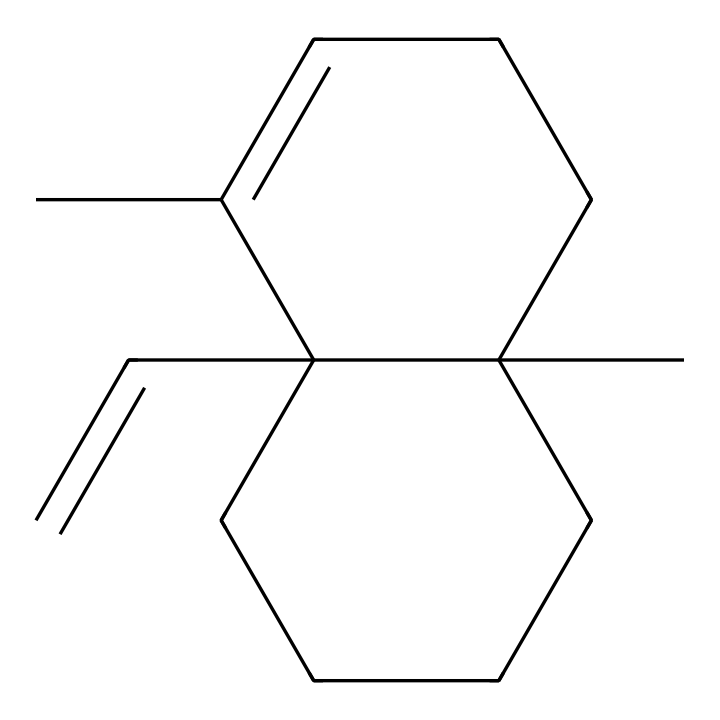What is the molecular formula of caryophyllene? To find the molecular formula, we count the number of carbon (C) and hydrogen (H) atoms in the structure. In the provided SMILES representation, there are 15 Carbon atoms and 24 Hydrogen atoms, leading to the molecular formula C15H24.
Answer: C15H24 How many rings are present in caryophyllene? The structure contains a bicyclic system, which indicates there are two rings in the compound. These rings are formed by connecting the carbons in the main chain, as seen in the structure.
Answer: 2 What is the characteristic feature of caryophyllene compared to other terpenes? Caryophyllene has a unique feature of a cyclobutene ring, which is less common among terpenes. This feature can be identified through the bicyclic nature of its structure that includes the double bond in the ring formation.
Answer: cyclobutene ring What type of bond is present between the carbon atoms in caryophyllene? The structure shows both single (σ) and double (π) bonds between carbon atoms. The double bonds are identified from the presence of C=C in the structure, while the remaining connections are single bonds.
Answer: single and double bonds Is caryophyllene a saturated or unsaturated compound? Due to the presence of double bonds between some of the carbon atoms in the structure, caryophyllene is classified as an unsaturated compound. This classification is driven by the existence of C=C bonds in the bicyclic structure.
Answer: unsaturated 